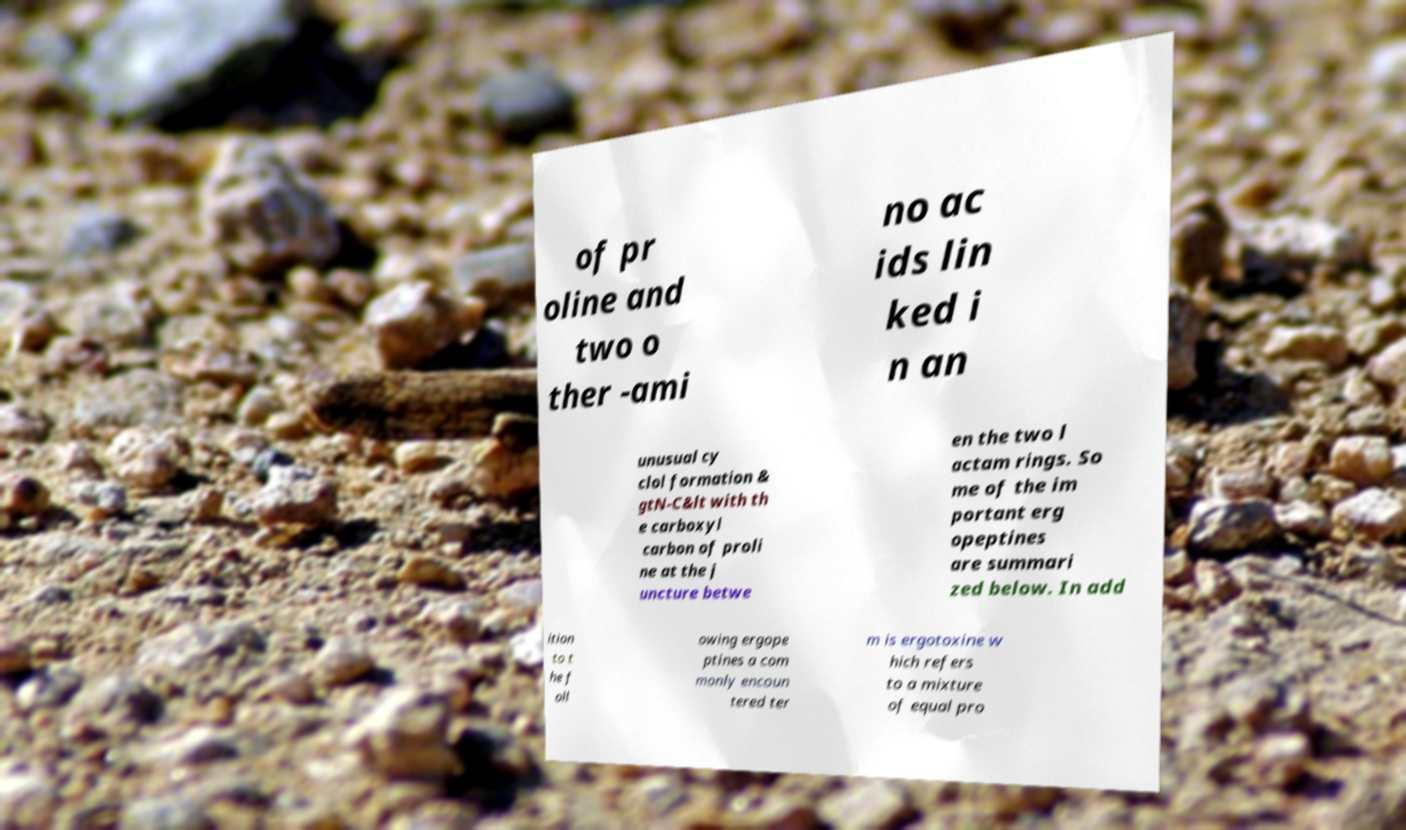Can you accurately transcribe the text from the provided image for me? of pr oline and two o ther -ami no ac ids lin ked i n an unusual cy clol formation & gtN-C&lt with th e carboxyl carbon of proli ne at the j uncture betwe en the two l actam rings. So me of the im portant erg opeptines are summari zed below. In add ition to t he f oll owing ergope ptines a com monly encoun tered ter m is ergotoxine w hich refers to a mixture of equal pro 